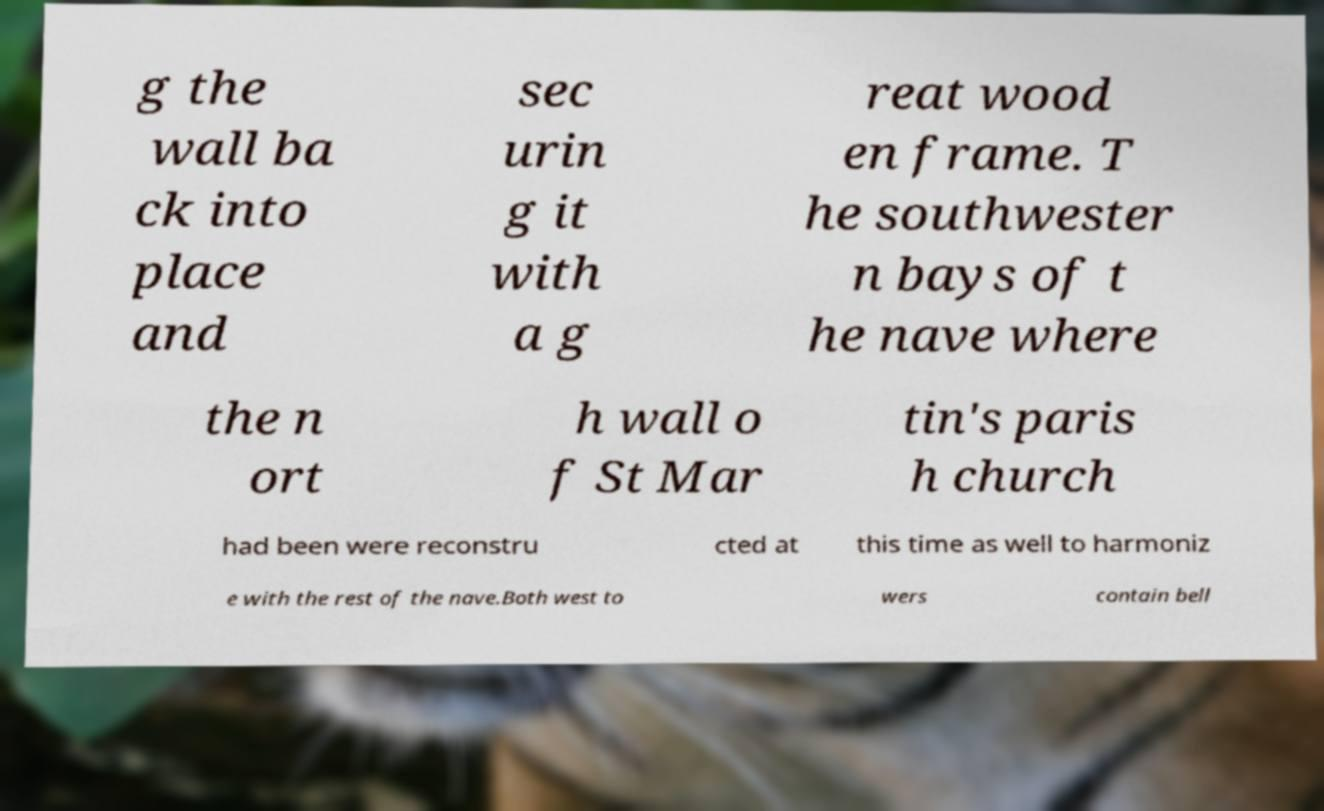Can you read and provide the text displayed in the image?This photo seems to have some interesting text. Can you extract and type it out for me? g the wall ba ck into place and sec urin g it with a g reat wood en frame. T he southwester n bays of t he nave where the n ort h wall o f St Mar tin's paris h church had been were reconstru cted at this time as well to harmoniz e with the rest of the nave.Both west to wers contain bell 